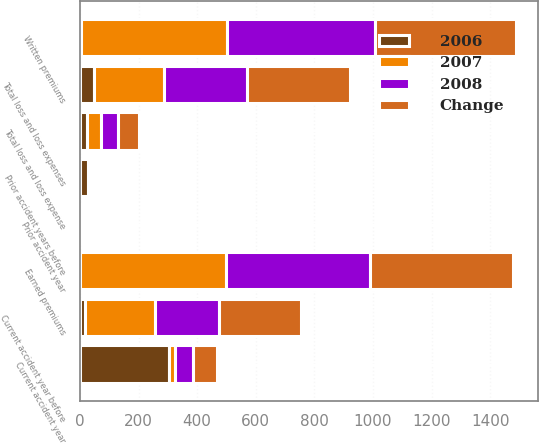Convert chart to OTSL. <chart><loc_0><loc_0><loc_500><loc_500><stacked_bar_chart><ecel><fcel>Written premiums<fcel>Earned premiums<fcel>Current accident year before<fcel>Current accident year<fcel>Prior accident years before<fcel>Total loss and loss expenses<fcel>Prior accident year<fcel>Total loss and loss expense<nl><fcel>Change<fcel>481<fcel>487<fcel>282<fcel>81<fcel>7<fcel>353<fcel>0.4<fcel>72.6<nl><fcel>2007<fcel>499<fcel>497<fcel>240<fcel>20<fcel>10<fcel>241<fcel>1.8<fcel>48.5<nl><fcel>2008<fcel>505<fcel>491<fcel>216<fcel>62<fcel>2<fcel>282<fcel>1.3<fcel>57.5<nl><fcel>2006<fcel>3.6<fcel>2<fcel>17.3<fcel>304.2<fcel>29.1<fcel>46.7<fcel>1.4<fcel>24.1<nl></chart> 